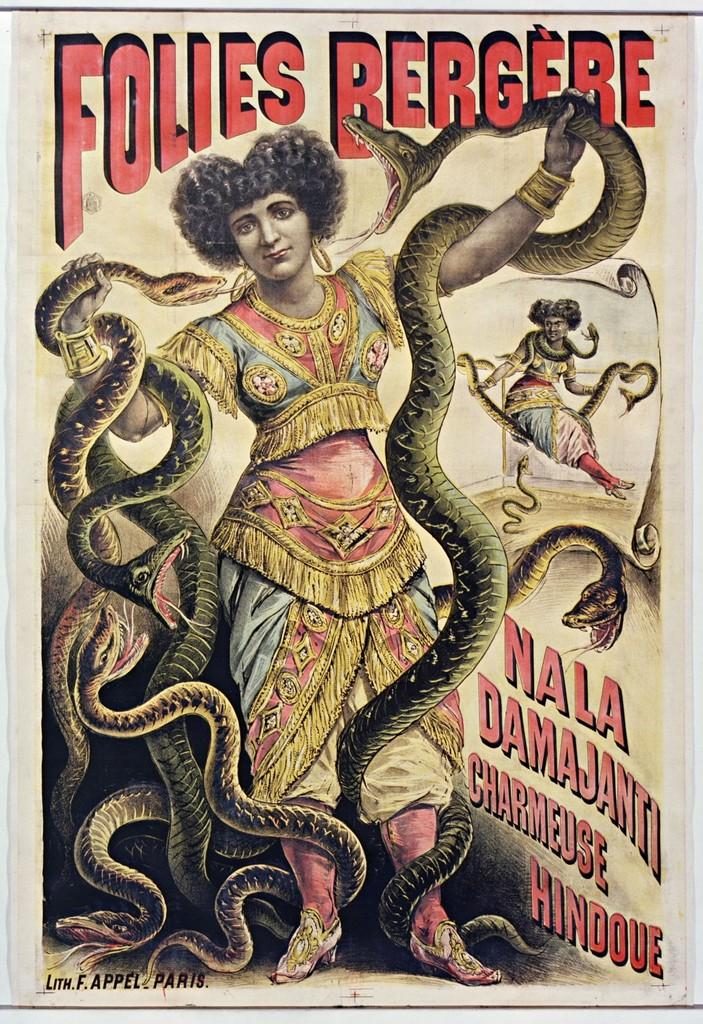What type of visual content is depicted in the image? The image appears to be a poster. How many people are featured in the poster? There are two persons in the poster. What are the persons holding in their hands? The persons are holding snakes in their hands. Is there any text present on the poster? Yes, there is text present on the poster. Where is the nearest park to the location depicted in the poster? The poster does not depict a specific location, so it is not possible to determine the nearest park. 